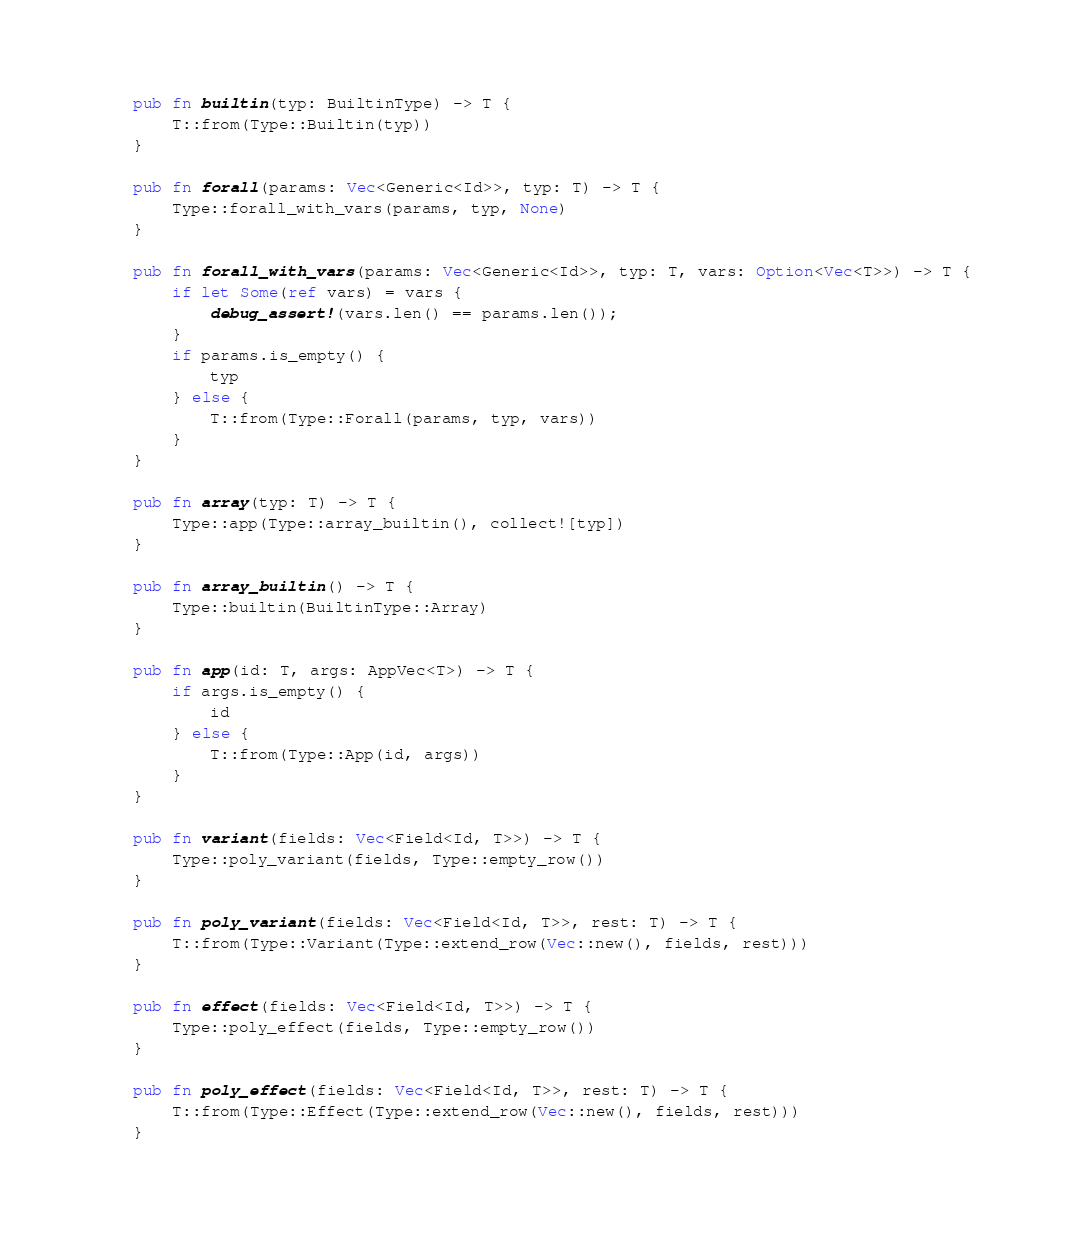Convert code to text. <code><loc_0><loc_0><loc_500><loc_500><_Rust_>    pub fn builtin(typ: BuiltinType) -> T {
        T::from(Type::Builtin(typ))
    }

    pub fn forall(params: Vec<Generic<Id>>, typ: T) -> T {
        Type::forall_with_vars(params, typ, None)
    }

    pub fn forall_with_vars(params: Vec<Generic<Id>>, typ: T, vars: Option<Vec<T>>) -> T {
        if let Some(ref vars) = vars {
            debug_assert!(vars.len() == params.len());
        }
        if params.is_empty() {
            typ
        } else {
            T::from(Type::Forall(params, typ, vars))
        }
    }

    pub fn array(typ: T) -> T {
        Type::app(Type::array_builtin(), collect![typ])
    }

    pub fn array_builtin() -> T {
        Type::builtin(BuiltinType::Array)
    }

    pub fn app(id: T, args: AppVec<T>) -> T {
        if args.is_empty() {
            id
        } else {
            T::from(Type::App(id, args))
        }
    }

    pub fn variant(fields: Vec<Field<Id, T>>) -> T {
        Type::poly_variant(fields, Type::empty_row())
    }

    pub fn poly_variant(fields: Vec<Field<Id, T>>, rest: T) -> T {
        T::from(Type::Variant(Type::extend_row(Vec::new(), fields, rest)))
    }

    pub fn effect(fields: Vec<Field<Id, T>>) -> T {
        Type::poly_effect(fields, Type::empty_row())
    }

    pub fn poly_effect(fields: Vec<Field<Id, T>>, rest: T) -> T {
        T::from(Type::Effect(Type::extend_row(Vec::new(), fields, rest)))
    }
</code> 